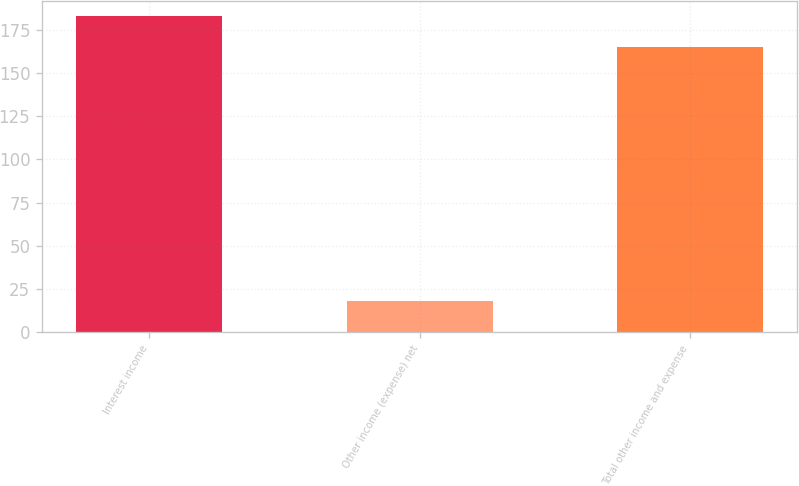<chart> <loc_0><loc_0><loc_500><loc_500><bar_chart><fcel>Interest income<fcel>Other income (expense) net<fcel>Total other income and expense<nl><fcel>183<fcel>18<fcel>165<nl></chart> 